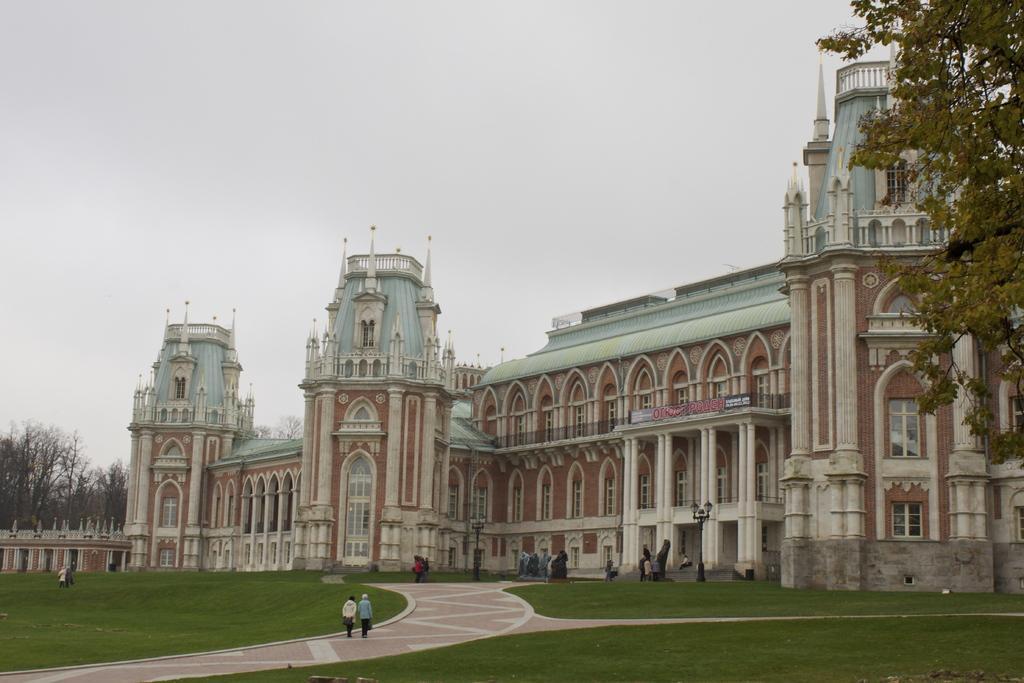How would you summarize this image in a sentence or two? In this image there is a palace, in front of the palace there is a garden and path, people are walking on path and in garden, on left side and right side there are trees, in the background there are sky. 